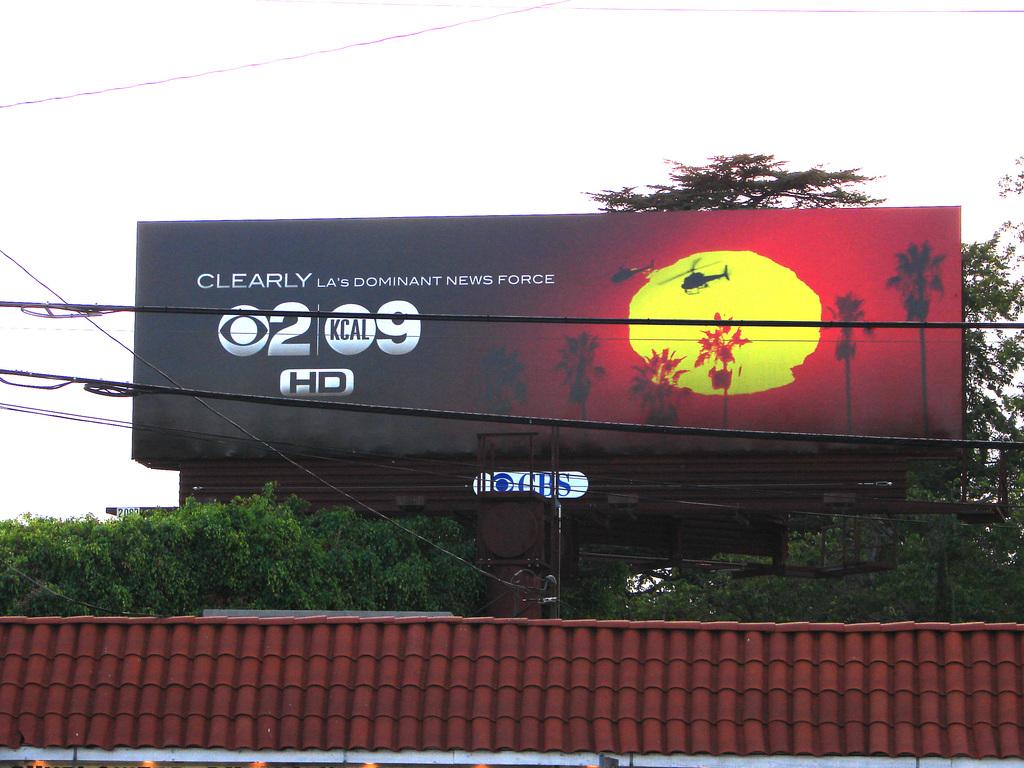What channel is the show on?
Provide a short and direct response. 2. What is the station name?
Make the answer very short. Kcal. 